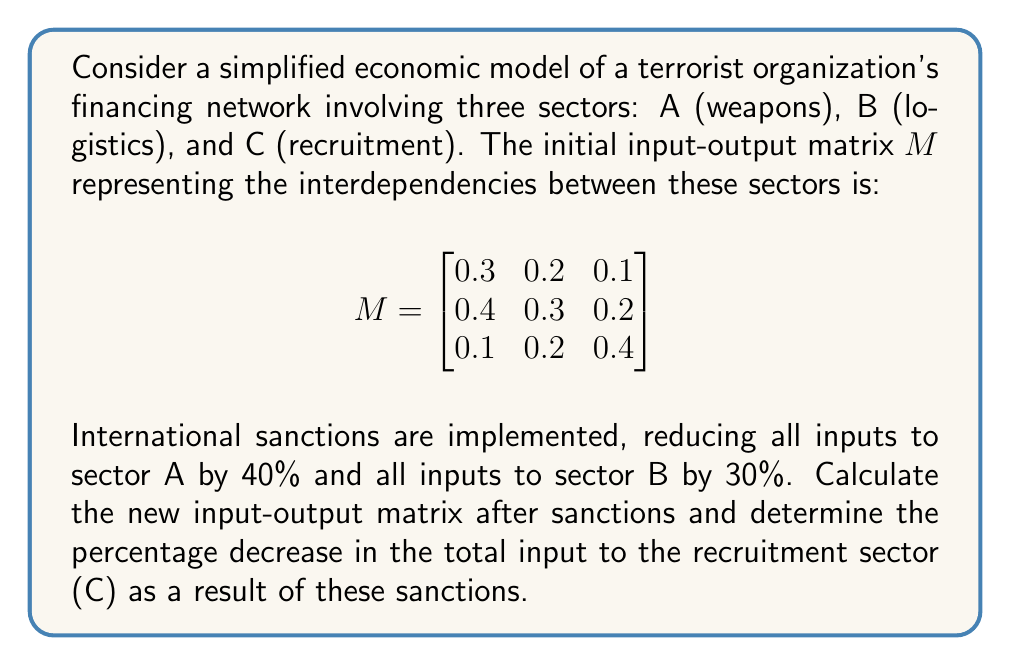Help me with this question. Let's approach this step-by-step:

1) First, we need to calculate the new input-output matrix after sanctions. The sanctions reduce inputs to sector A by 40% and to sector B by 30%. This means we need to multiply the first column by 0.6 and the second column by 0.7:

   $$M_{new} = \begin{bmatrix}
   0.3 * 0.6 & 0.2 * 0.7 & 0.1 \\
   0.4 * 0.6 & 0.3 * 0.7 & 0.2 \\
   0.1 * 0.6 & 0.2 * 0.7 & 0.4
   \end{bmatrix}$$

2) Calculating the new matrix:

   $$M_{new} = \begin{bmatrix}
   0.18 & 0.14 & 0.1 \\
   0.24 & 0.21 & 0.2 \\
   0.06 & 0.14 & 0.4
   \end{bmatrix}$$

3) To find the total input to sector C, we sum the elements in the third column of each matrix:

   Original total input to C: $0.1 + 0.2 + 0.4 = 0.7$
   New total input to C: $0.1 + 0.2 + 0.4 = 0.7$

4) The total input to sector C hasn't changed, as the sanctions didn't directly affect this column.

5) Therefore, the percentage decrease in the total input to the recruitment sector (C) is 0%.
Answer: 0% 